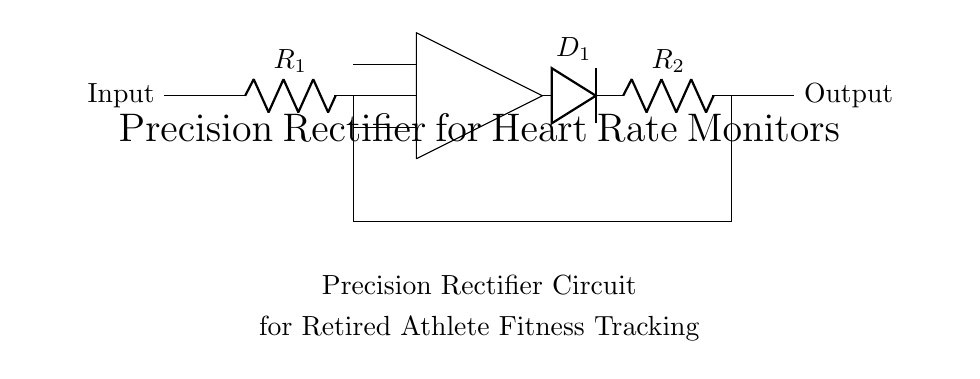What is the value of R1? The circuit diagram does not specify an exact numerical value for R1, but it is labeled as R1. We infer that it is part of the circuit used to define the input characteristics.
Answer: R1 What is the function of D1 in this circuit? D1 is a diode, which allows current to flow in one direction only. In the precision rectifier setup, it ensures that the output voltage reflects the input voltage when it is positive, effectively preventing negative signals from passing through.
Answer: Rectification What is connected to D1's anode? The anode of D1 is connected directly to the output of the operational amplifier. This means that when the operational amplifier outputs a positive voltage, D1 will conduct, allowing the output voltage to reflect that positive value.
Answer: Op-amp How many resistors are in this circuit? There are two resistors, R1 and R2, as explicitly labeled in the circuit diagram. They are vital for setting the gain and controlling the precision of the rectification process.
Answer: Two What is the role of the operational amplifier in this precision rectifier? The operational amplifier amplifies the input signal. It is crucial in the precision rectifier because it allows the circuit to accurately track the positive portions of the input signal and corrects the output accordingly.
Answer: Amplification What type of circuit is this? This is a precision rectifier circuit, often utilized in applications that require accurate rectification of small signals, such as in heart rate monitors and fitness tracking, to ensure precise readings.
Answer: Rectifier 